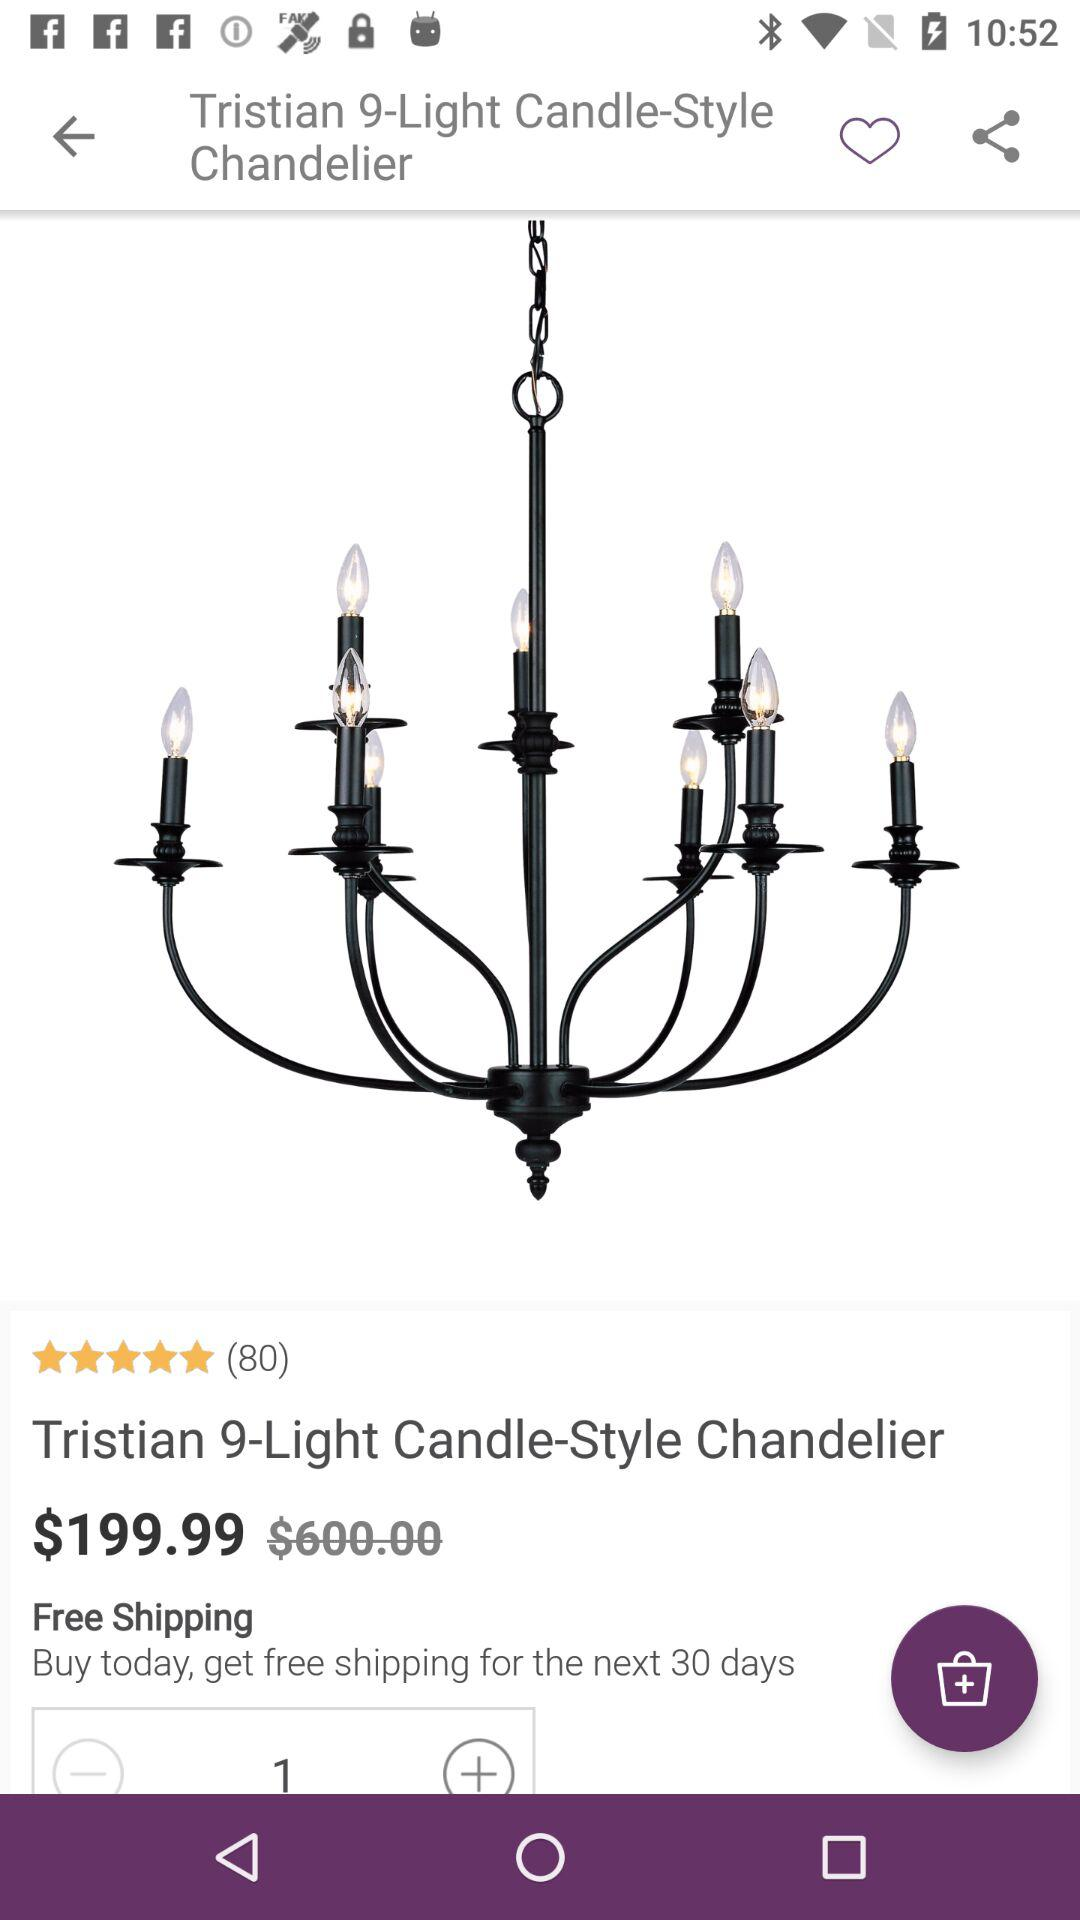For the next how many days will we get free shipping if we buy today? If you buy today, you will get free shipping for the next 30 days. 